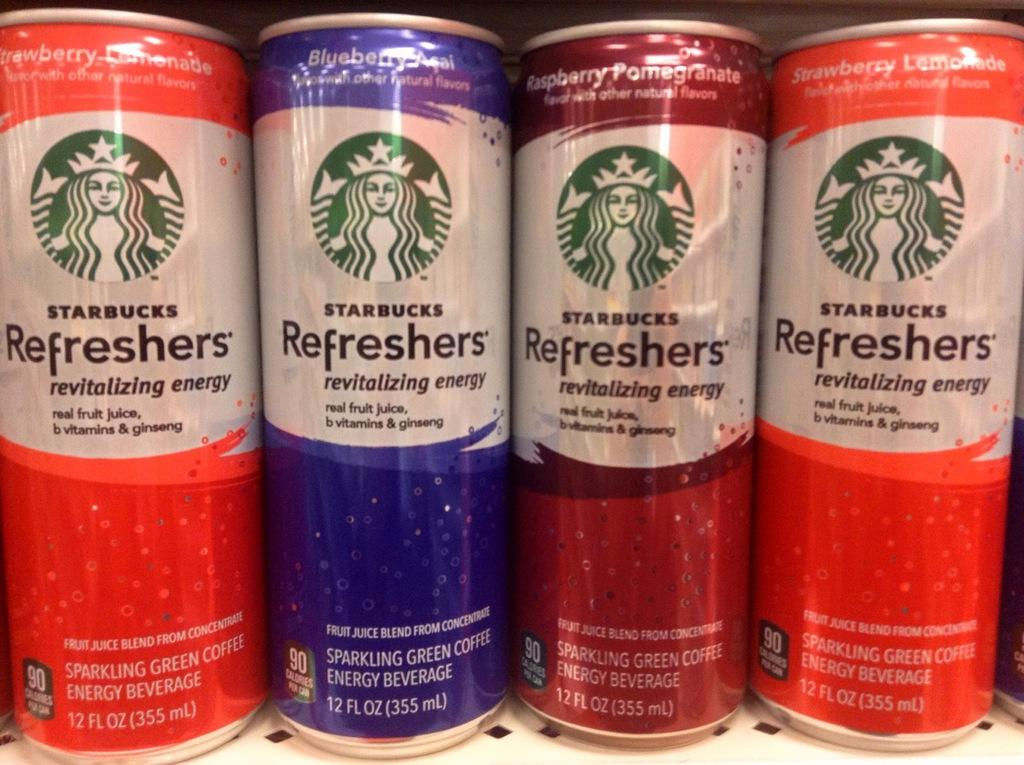<image>
Summarize the visual content of the image. A row of Starbucks refreshers in different flavors. 